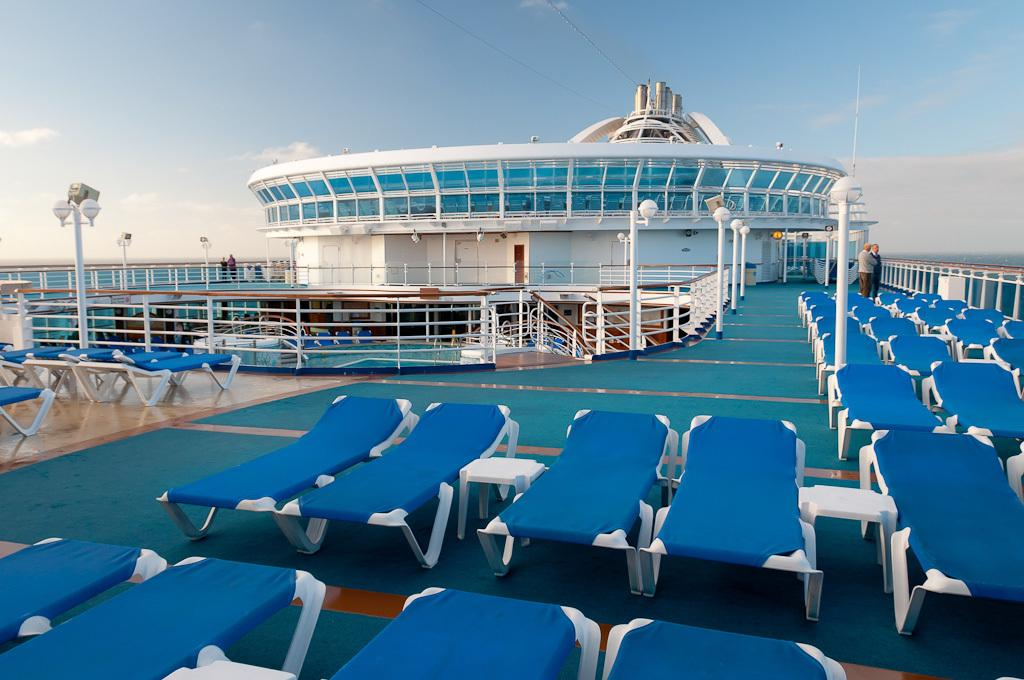Where was the image taken? The image was taken on the top of a ferry. What type of seating can be seen in the image? There are sun loungers in the image. What is present in the background of the image? There is a railing and an architectural structure visible in the background. What can be seen above the ferry in the image? The sky is visible in the image. What is the square's role in the war depicted in the image? There is no square or war depicted in the image; it shows a ferry with sun loungers and a background with a railing and an architectural structure. 